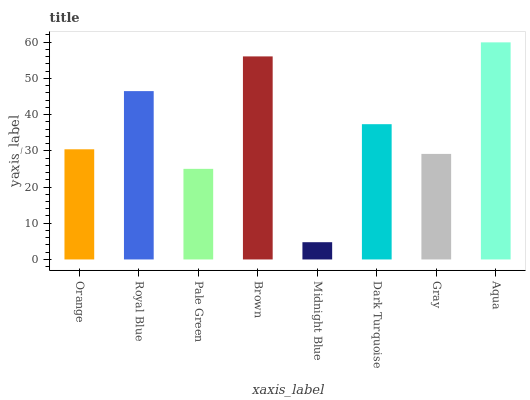Is Midnight Blue the minimum?
Answer yes or no. Yes. Is Aqua the maximum?
Answer yes or no. Yes. Is Royal Blue the minimum?
Answer yes or no. No. Is Royal Blue the maximum?
Answer yes or no. No. Is Royal Blue greater than Orange?
Answer yes or no. Yes. Is Orange less than Royal Blue?
Answer yes or no. Yes. Is Orange greater than Royal Blue?
Answer yes or no. No. Is Royal Blue less than Orange?
Answer yes or no. No. Is Dark Turquoise the high median?
Answer yes or no. Yes. Is Orange the low median?
Answer yes or no. Yes. Is Brown the high median?
Answer yes or no. No. Is Royal Blue the low median?
Answer yes or no. No. 